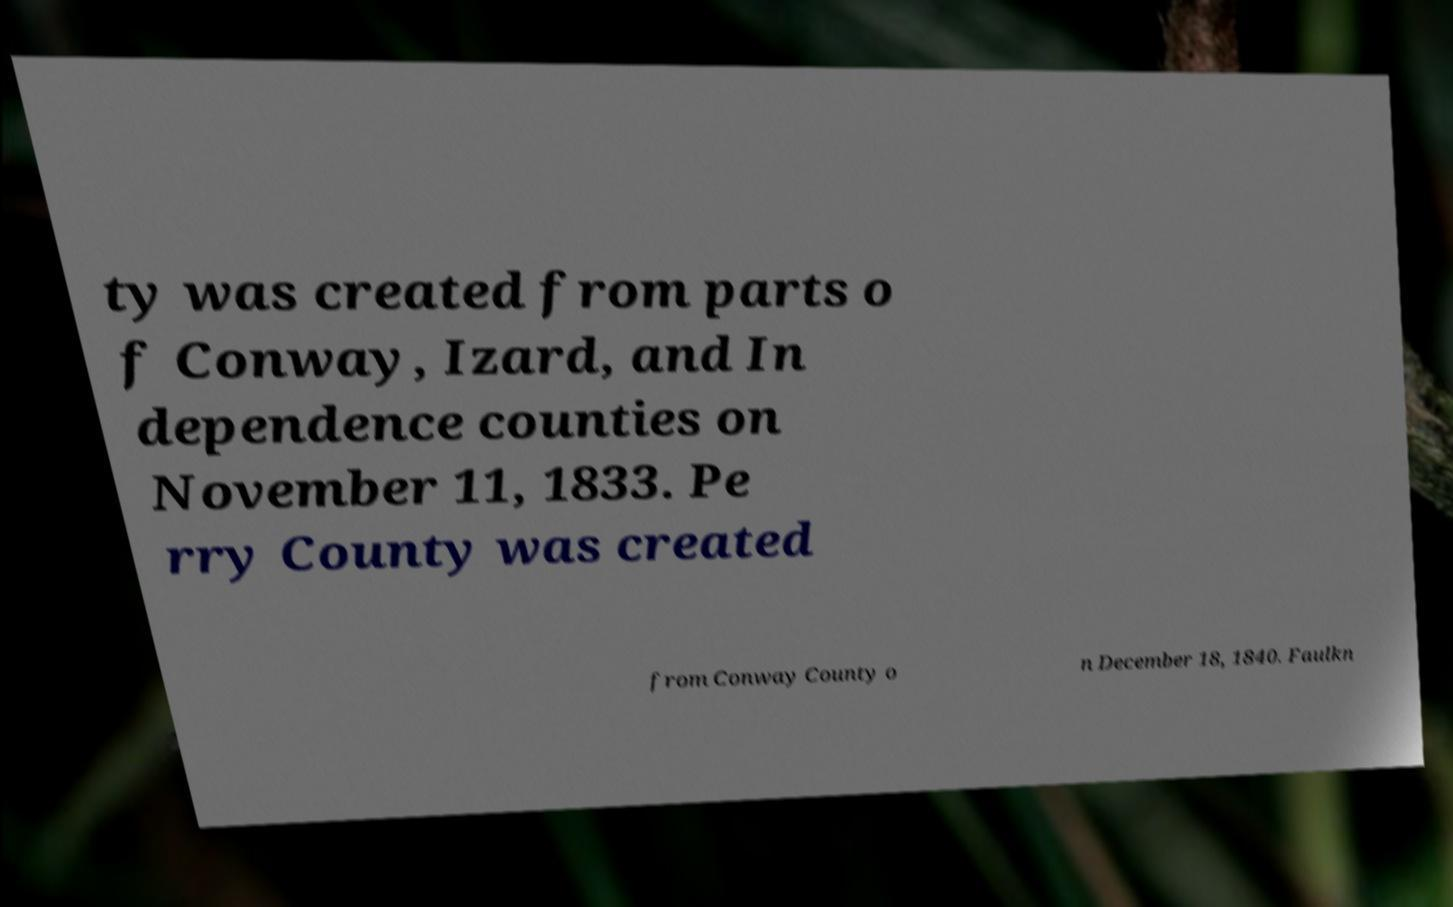What messages or text are displayed in this image? I need them in a readable, typed format. ty was created from parts o f Conway, Izard, and In dependence counties on November 11, 1833. Pe rry County was created from Conway County o n December 18, 1840. Faulkn 